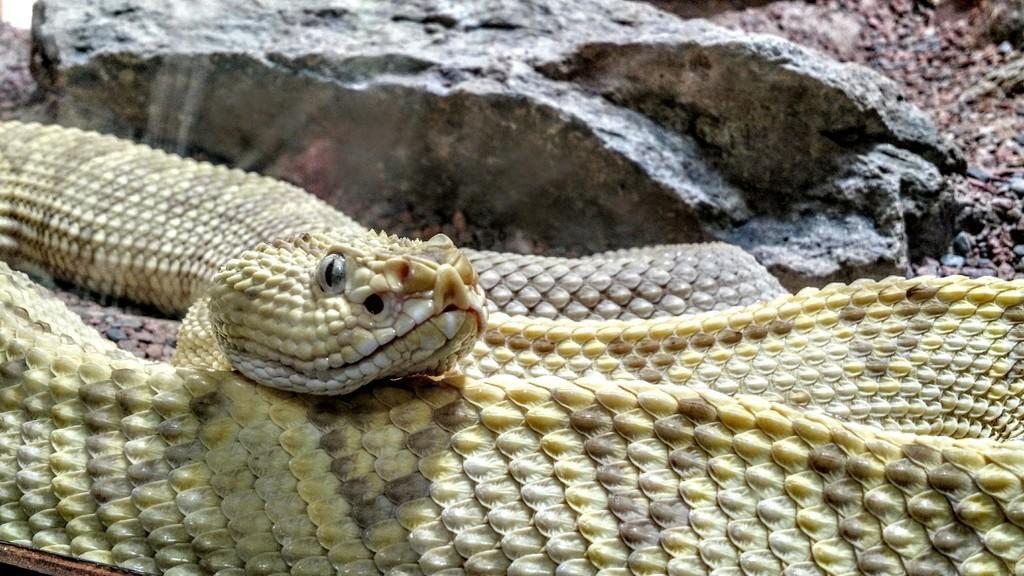Describe this image in one or two sentences. In this picture we can see snake, rock and stones. 